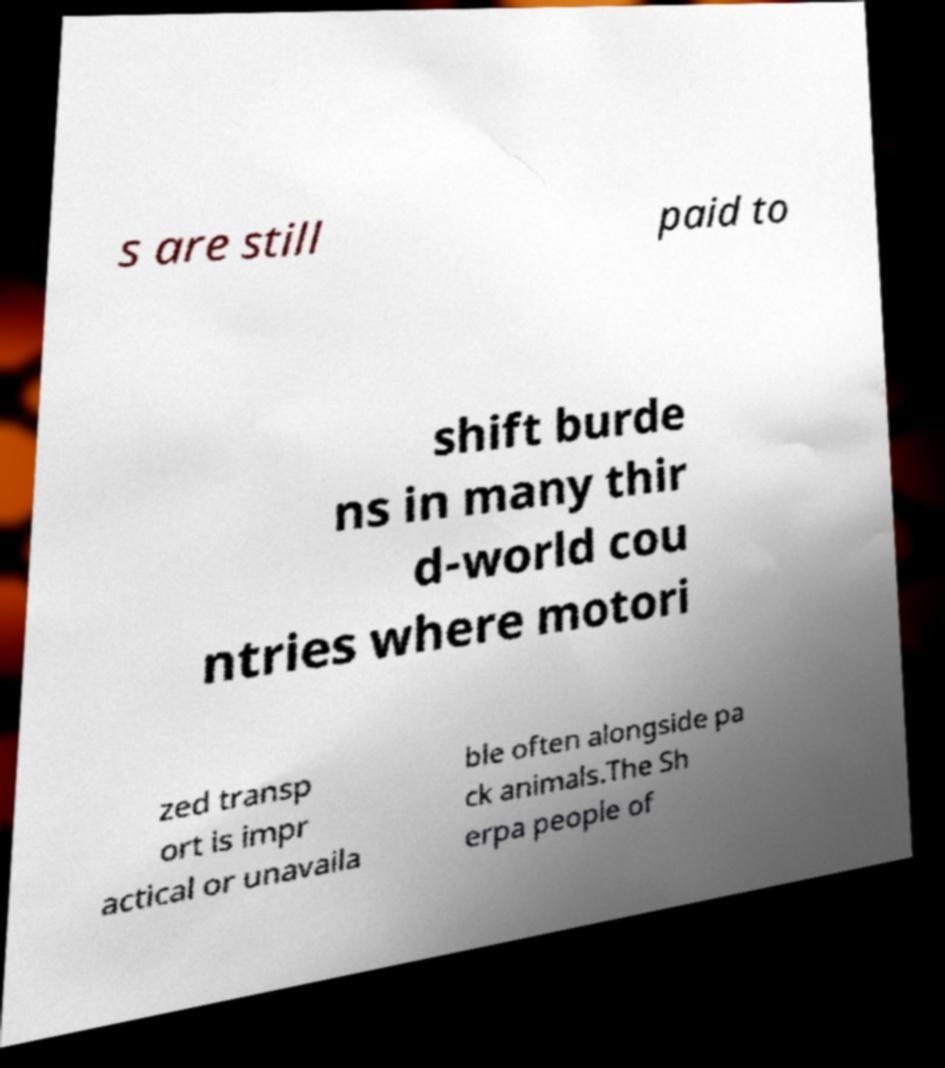Could you extract and type out the text from this image? s are still paid to shift burde ns in many thir d-world cou ntries where motori zed transp ort is impr actical or unavaila ble often alongside pa ck animals.The Sh erpa people of 